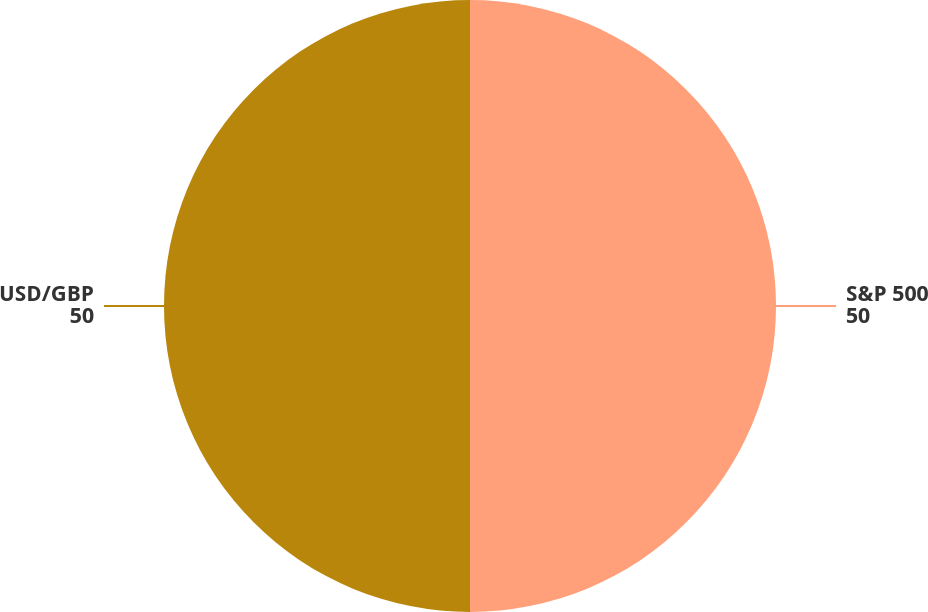Convert chart to OTSL. <chart><loc_0><loc_0><loc_500><loc_500><pie_chart><fcel>S&P 500<fcel>USD/GBP<nl><fcel>50.0%<fcel>50.0%<nl></chart> 